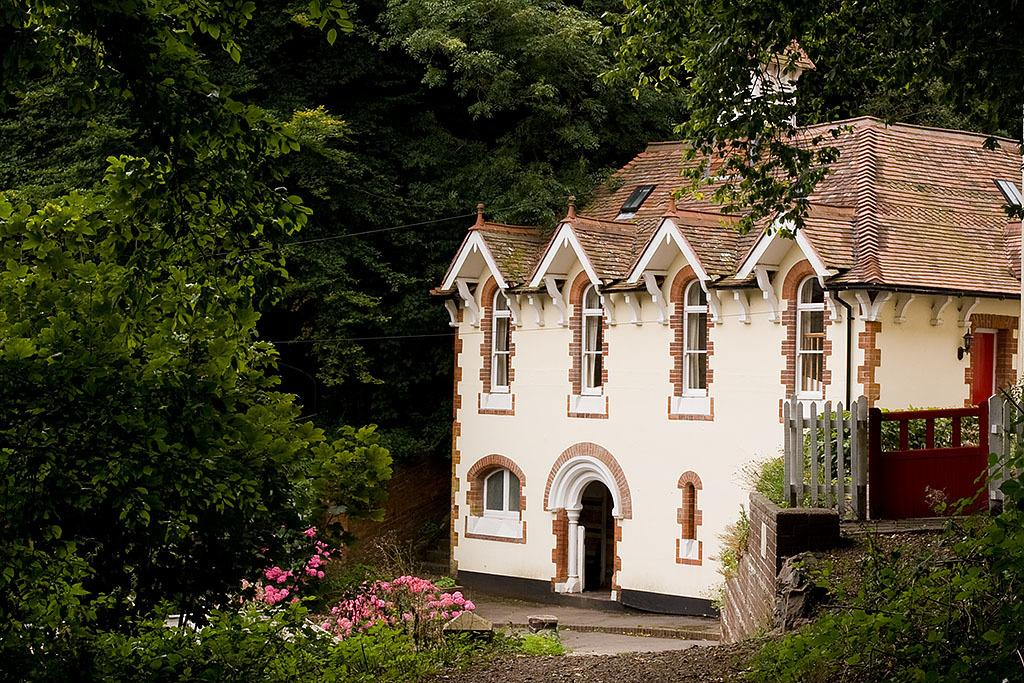What type of view is shown in the image? The image is an outside view. What can be seen on the right side of the image? There is a building on the right side of the image. What is present on the left side of the image? There are many trees on the left side of the image. What is visible at the bottom of the image? Plants and flowers are visible at the bottom of the image. What type of religious symbol can be seen on the building in the image? There is no religious symbol visible on the building in the image. How does friction affect the movement of the plants in the image? There is no movement of plants in the image, and therefore friction does not affect them. 